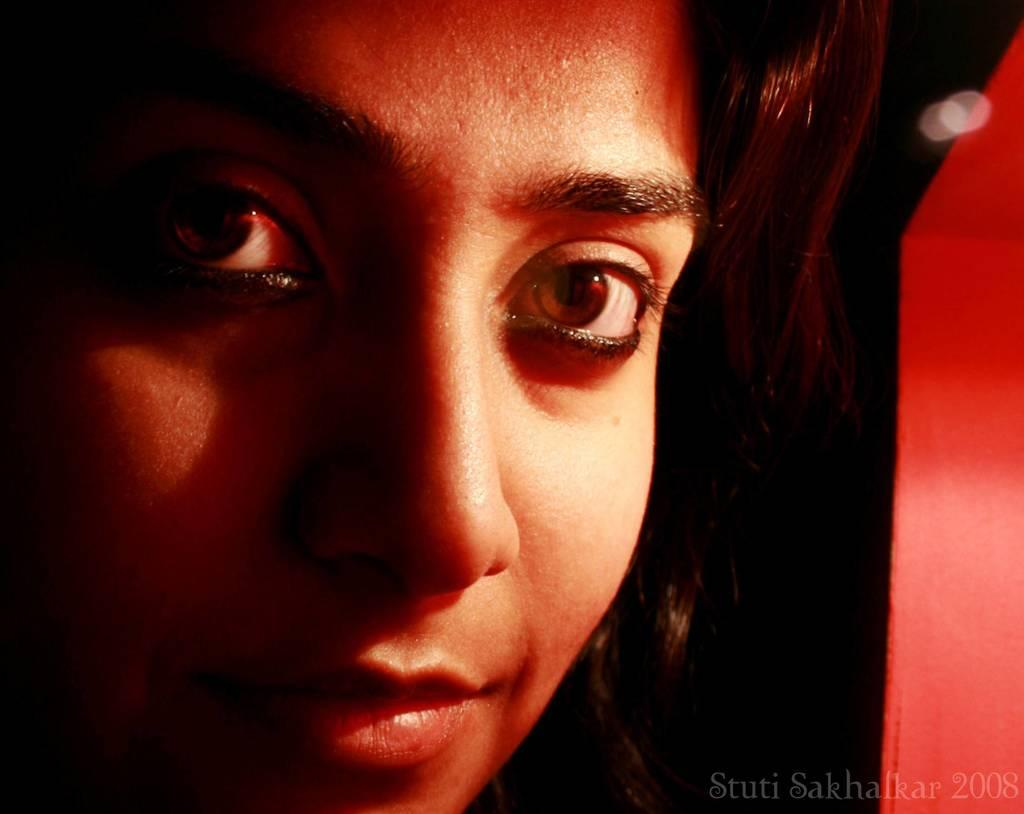What is the main subject of the image? There is a lady's face in the image. Can you describe any additional elements in the image? There is text in the right bottom corner of the image. Is there a patch of grass visible in the image? There is no patch of grass present in the image; it only features a lady's face and text in the right bottom corner. 